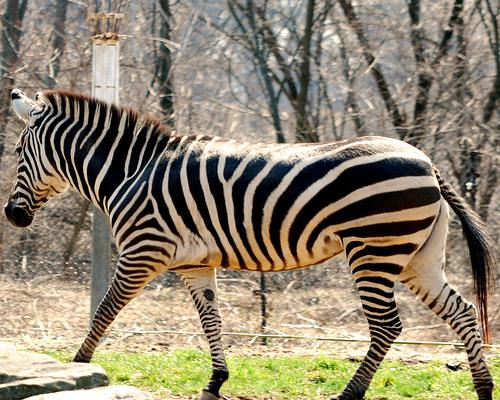Question: where is the zebra?
Choices:
A. Savannah.
B. Park.
C. Zoo.
D. Grassland.
Answer with the letter. Answer: C Question: what is it?
Choices:
A. Zebra.
B. Elephant.
C. Giraffe.
D. Lion.
Answer with the letter. Answer: A 